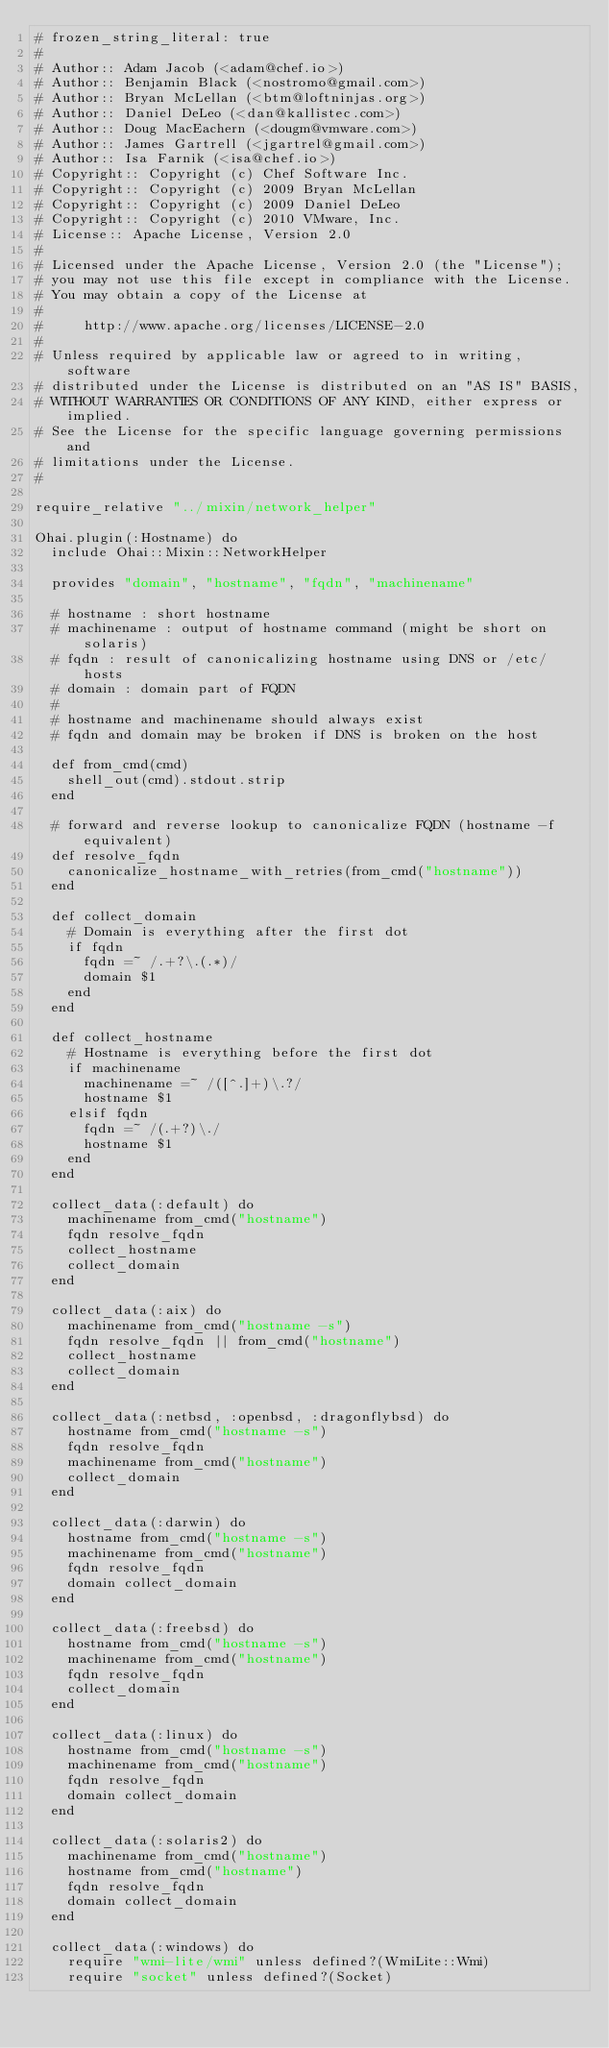<code> <loc_0><loc_0><loc_500><loc_500><_Ruby_># frozen_string_literal: true
#
# Author:: Adam Jacob (<adam@chef.io>)
# Author:: Benjamin Black (<nostromo@gmail.com>)
# Author:: Bryan McLellan (<btm@loftninjas.org>)
# Author:: Daniel DeLeo (<dan@kallistec.com>)
# Author:: Doug MacEachern (<dougm@vmware.com>)
# Author:: James Gartrell (<jgartrel@gmail.com>)
# Author:: Isa Farnik (<isa@chef.io>)
# Copyright:: Copyright (c) Chef Software Inc.
# Copyright:: Copyright (c) 2009 Bryan McLellan
# Copyright:: Copyright (c) 2009 Daniel DeLeo
# Copyright:: Copyright (c) 2010 VMware, Inc.
# License:: Apache License, Version 2.0
#
# Licensed under the Apache License, Version 2.0 (the "License");
# you may not use this file except in compliance with the License.
# You may obtain a copy of the License at
#
#     http://www.apache.org/licenses/LICENSE-2.0
#
# Unless required by applicable law or agreed to in writing, software
# distributed under the License is distributed on an "AS IS" BASIS,
# WITHOUT WARRANTIES OR CONDITIONS OF ANY KIND, either express or implied.
# See the License for the specific language governing permissions and
# limitations under the License.
#

require_relative "../mixin/network_helper"

Ohai.plugin(:Hostname) do
  include Ohai::Mixin::NetworkHelper

  provides "domain", "hostname", "fqdn", "machinename"

  # hostname : short hostname
  # machinename : output of hostname command (might be short on solaris)
  # fqdn : result of canonicalizing hostname using DNS or /etc/hosts
  # domain : domain part of FQDN
  #
  # hostname and machinename should always exist
  # fqdn and domain may be broken if DNS is broken on the host

  def from_cmd(cmd)
    shell_out(cmd).stdout.strip
  end

  # forward and reverse lookup to canonicalize FQDN (hostname -f equivalent)
  def resolve_fqdn
    canonicalize_hostname_with_retries(from_cmd("hostname"))
  end

  def collect_domain
    # Domain is everything after the first dot
    if fqdn
      fqdn =~ /.+?\.(.*)/
      domain $1
    end
  end

  def collect_hostname
    # Hostname is everything before the first dot
    if machinename
      machinename =~ /([^.]+)\.?/
      hostname $1
    elsif fqdn
      fqdn =~ /(.+?)\./
      hostname $1
    end
  end

  collect_data(:default) do
    machinename from_cmd("hostname")
    fqdn resolve_fqdn
    collect_hostname
    collect_domain
  end

  collect_data(:aix) do
    machinename from_cmd("hostname -s")
    fqdn resolve_fqdn || from_cmd("hostname")
    collect_hostname
    collect_domain
  end

  collect_data(:netbsd, :openbsd, :dragonflybsd) do
    hostname from_cmd("hostname -s")
    fqdn resolve_fqdn
    machinename from_cmd("hostname")
    collect_domain
  end

  collect_data(:darwin) do
    hostname from_cmd("hostname -s")
    machinename from_cmd("hostname")
    fqdn resolve_fqdn
    domain collect_domain
  end

  collect_data(:freebsd) do
    hostname from_cmd("hostname -s")
    machinename from_cmd("hostname")
    fqdn resolve_fqdn
    collect_domain
  end

  collect_data(:linux) do
    hostname from_cmd("hostname -s")
    machinename from_cmd("hostname")
    fqdn resolve_fqdn
    domain collect_domain
  end

  collect_data(:solaris2) do
    machinename from_cmd("hostname")
    hostname from_cmd("hostname")
    fqdn resolve_fqdn
    domain collect_domain
  end

  collect_data(:windows) do
    require "wmi-lite/wmi" unless defined?(WmiLite::Wmi)
    require "socket" unless defined?(Socket)
</code> 